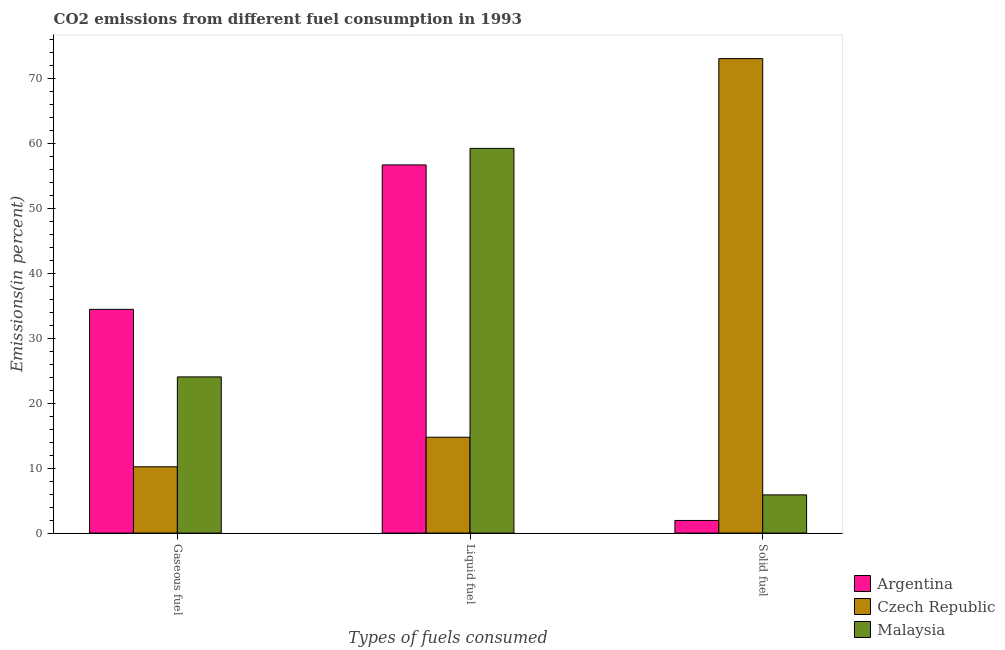How many different coloured bars are there?
Make the answer very short. 3. What is the label of the 2nd group of bars from the left?
Give a very brief answer. Liquid fuel. What is the percentage of gaseous fuel emission in Czech Republic?
Offer a very short reply. 10.2. Across all countries, what is the maximum percentage of liquid fuel emission?
Ensure brevity in your answer.  59.21. Across all countries, what is the minimum percentage of liquid fuel emission?
Provide a succinct answer. 14.75. In which country was the percentage of solid fuel emission maximum?
Provide a succinct answer. Czech Republic. In which country was the percentage of liquid fuel emission minimum?
Give a very brief answer. Czech Republic. What is the total percentage of solid fuel emission in the graph?
Keep it short and to the point. 80.84. What is the difference between the percentage of liquid fuel emission in Malaysia and that in Argentina?
Give a very brief answer. 2.54. What is the difference between the percentage of solid fuel emission in Argentina and the percentage of liquid fuel emission in Czech Republic?
Offer a very short reply. -12.81. What is the average percentage of gaseous fuel emission per country?
Offer a terse response. 22.89. What is the difference between the percentage of liquid fuel emission and percentage of gaseous fuel emission in Malaysia?
Make the answer very short. 35.17. In how many countries, is the percentage of solid fuel emission greater than 40 %?
Offer a terse response. 1. What is the ratio of the percentage of solid fuel emission in Czech Republic to that in Malaysia?
Your answer should be compact. 12.43. Is the percentage of liquid fuel emission in Malaysia less than that in Czech Republic?
Give a very brief answer. No. What is the difference between the highest and the second highest percentage of liquid fuel emission?
Offer a very short reply. 2.54. What is the difference between the highest and the lowest percentage of solid fuel emission?
Give a very brief answer. 71.08. In how many countries, is the percentage of solid fuel emission greater than the average percentage of solid fuel emission taken over all countries?
Your answer should be very brief. 1. Is the sum of the percentage of liquid fuel emission in Czech Republic and Malaysia greater than the maximum percentage of gaseous fuel emission across all countries?
Make the answer very short. Yes. What does the 1st bar from the left in Solid fuel represents?
Your response must be concise. Argentina. What does the 1st bar from the right in Liquid fuel represents?
Your answer should be very brief. Malaysia. Is it the case that in every country, the sum of the percentage of gaseous fuel emission and percentage of liquid fuel emission is greater than the percentage of solid fuel emission?
Your response must be concise. No. Are the values on the major ticks of Y-axis written in scientific E-notation?
Your answer should be very brief. No. Where does the legend appear in the graph?
Ensure brevity in your answer.  Bottom right. What is the title of the graph?
Your response must be concise. CO2 emissions from different fuel consumption in 1993. What is the label or title of the X-axis?
Provide a succinct answer. Types of fuels consumed. What is the label or title of the Y-axis?
Your response must be concise. Emissions(in percent). What is the Emissions(in percent) in Argentina in Gaseous fuel?
Your response must be concise. 34.43. What is the Emissions(in percent) of Czech Republic in Gaseous fuel?
Offer a terse response. 10.2. What is the Emissions(in percent) of Malaysia in Gaseous fuel?
Your response must be concise. 24.04. What is the Emissions(in percent) of Argentina in Liquid fuel?
Make the answer very short. 56.66. What is the Emissions(in percent) in Czech Republic in Liquid fuel?
Your answer should be compact. 14.75. What is the Emissions(in percent) in Malaysia in Liquid fuel?
Your answer should be very brief. 59.21. What is the Emissions(in percent) of Argentina in Solid fuel?
Make the answer very short. 1.94. What is the Emissions(in percent) of Czech Republic in Solid fuel?
Offer a terse response. 73.03. What is the Emissions(in percent) of Malaysia in Solid fuel?
Give a very brief answer. 5.88. Across all Types of fuels consumed, what is the maximum Emissions(in percent) in Argentina?
Your answer should be very brief. 56.66. Across all Types of fuels consumed, what is the maximum Emissions(in percent) in Czech Republic?
Provide a short and direct response. 73.03. Across all Types of fuels consumed, what is the maximum Emissions(in percent) in Malaysia?
Offer a terse response. 59.21. Across all Types of fuels consumed, what is the minimum Emissions(in percent) of Argentina?
Make the answer very short. 1.94. Across all Types of fuels consumed, what is the minimum Emissions(in percent) in Czech Republic?
Ensure brevity in your answer.  10.2. Across all Types of fuels consumed, what is the minimum Emissions(in percent) in Malaysia?
Give a very brief answer. 5.88. What is the total Emissions(in percent) in Argentina in the graph?
Give a very brief answer. 93.03. What is the total Emissions(in percent) of Czech Republic in the graph?
Give a very brief answer. 97.98. What is the total Emissions(in percent) of Malaysia in the graph?
Ensure brevity in your answer.  89.12. What is the difference between the Emissions(in percent) in Argentina in Gaseous fuel and that in Liquid fuel?
Provide a succinct answer. -22.23. What is the difference between the Emissions(in percent) of Czech Republic in Gaseous fuel and that in Liquid fuel?
Offer a very short reply. -4.55. What is the difference between the Emissions(in percent) in Malaysia in Gaseous fuel and that in Liquid fuel?
Provide a succinct answer. -35.17. What is the difference between the Emissions(in percent) of Argentina in Gaseous fuel and that in Solid fuel?
Give a very brief answer. 32.49. What is the difference between the Emissions(in percent) in Czech Republic in Gaseous fuel and that in Solid fuel?
Provide a short and direct response. -62.82. What is the difference between the Emissions(in percent) of Malaysia in Gaseous fuel and that in Solid fuel?
Provide a short and direct response. 18.16. What is the difference between the Emissions(in percent) in Argentina in Liquid fuel and that in Solid fuel?
Provide a succinct answer. 54.72. What is the difference between the Emissions(in percent) of Czech Republic in Liquid fuel and that in Solid fuel?
Offer a terse response. -58.28. What is the difference between the Emissions(in percent) of Malaysia in Liquid fuel and that in Solid fuel?
Ensure brevity in your answer.  53.33. What is the difference between the Emissions(in percent) in Argentina in Gaseous fuel and the Emissions(in percent) in Czech Republic in Liquid fuel?
Offer a terse response. 19.68. What is the difference between the Emissions(in percent) in Argentina in Gaseous fuel and the Emissions(in percent) in Malaysia in Liquid fuel?
Your answer should be compact. -24.77. What is the difference between the Emissions(in percent) in Czech Republic in Gaseous fuel and the Emissions(in percent) in Malaysia in Liquid fuel?
Provide a succinct answer. -49. What is the difference between the Emissions(in percent) of Argentina in Gaseous fuel and the Emissions(in percent) of Czech Republic in Solid fuel?
Provide a succinct answer. -38.59. What is the difference between the Emissions(in percent) in Argentina in Gaseous fuel and the Emissions(in percent) in Malaysia in Solid fuel?
Offer a very short reply. 28.55. What is the difference between the Emissions(in percent) of Czech Republic in Gaseous fuel and the Emissions(in percent) of Malaysia in Solid fuel?
Provide a short and direct response. 4.33. What is the difference between the Emissions(in percent) in Argentina in Liquid fuel and the Emissions(in percent) in Czech Republic in Solid fuel?
Provide a succinct answer. -16.36. What is the difference between the Emissions(in percent) of Argentina in Liquid fuel and the Emissions(in percent) of Malaysia in Solid fuel?
Keep it short and to the point. 50.78. What is the difference between the Emissions(in percent) in Czech Republic in Liquid fuel and the Emissions(in percent) in Malaysia in Solid fuel?
Your response must be concise. 8.87. What is the average Emissions(in percent) in Argentina per Types of fuels consumed?
Provide a succinct answer. 31.01. What is the average Emissions(in percent) in Czech Republic per Types of fuels consumed?
Your answer should be compact. 32.66. What is the average Emissions(in percent) in Malaysia per Types of fuels consumed?
Offer a very short reply. 29.71. What is the difference between the Emissions(in percent) in Argentina and Emissions(in percent) in Czech Republic in Gaseous fuel?
Make the answer very short. 24.23. What is the difference between the Emissions(in percent) in Argentina and Emissions(in percent) in Malaysia in Gaseous fuel?
Ensure brevity in your answer.  10.4. What is the difference between the Emissions(in percent) in Czech Republic and Emissions(in percent) in Malaysia in Gaseous fuel?
Offer a very short reply. -13.83. What is the difference between the Emissions(in percent) in Argentina and Emissions(in percent) in Czech Republic in Liquid fuel?
Your response must be concise. 41.91. What is the difference between the Emissions(in percent) in Argentina and Emissions(in percent) in Malaysia in Liquid fuel?
Your answer should be compact. -2.54. What is the difference between the Emissions(in percent) in Czech Republic and Emissions(in percent) in Malaysia in Liquid fuel?
Ensure brevity in your answer.  -44.46. What is the difference between the Emissions(in percent) in Argentina and Emissions(in percent) in Czech Republic in Solid fuel?
Offer a very short reply. -71.08. What is the difference between the Emissions(in percent) of Argentina and Emissions(in percent) of Malaysia in Solid fuel?
Make the answer very short. -3.94. What is the difference between the Emissions(in percent) in Czech Republic and Emissions(in percent) in Malaysia in Solid fuel?
Provide a succinct answer. 67.15. What is the ratio of the Emissions(in percent) of Argentina in Gaseous fuel to that in Liquid fuel?
Provide a short and direct response. 0.61. What is the ratio of the Emissions(in percent) in Czech Republic in Gaseous fuel to that in Liquid fuel?
Provide a short and direct response. 0.69. What is the ratio of the Emissions(in percent) in Malaysia in Gaseous fuel to that in Liquid fuel?
Provide a short and direct response. 0.41. What is the ratio of the Emissions(in percent) in Argentina in Gaseous fuel to that in Solid fuel?
Keep it short and to the point. 17.73. What is the ratio of the Emissions(in percent) of Czech Republic in Gaseous fuel to that in Solid fuel?
Your response must be concise. 0.14. What is the ratio of the Emissions(in percent) in Malaysia in Gaseous fuel to that in Solid fuel?
Ensure brevity in your answer.  4.09. What is the ratio of the Emissions(in percent) in Argentina in Liquid fuel to that in Solid fuel?
Keep it short and to the point. 29.18. What is the ratio of the Emissions(in percent) in Czech Republic in Liquid fuel to that in Solid fuel?
Make the answer very short. 0.2. What is the ratio of the Emissions(in percent) in Malaysia in Liquid fuel to that in Solid fuel?
Your response must be concise. 10.07. What is the difference between the highest and the second highest Emissions(in percent) of Argentina?
Ensure brevity in your answer.  22.23. What is the difference between the highest and the second highest Emissions(in percent) in Czech Republic?
Offer a terse response. 58.28. What is the difference between the highest and the second highest Emissions(in percent) in Malaysia?
Your answer should be very brief. 35.17. What is the difference between the highest and the lowest Emissions(in percent) of Argentina?
Your response must be concise. 54.72. What is the difference between the highest and the lowest Emissions(in percent) in Czech Republic?
Your answer should be very brief. 62.82. What is the difference between the highest and the lowest Emissions(in percent) of Malaysia?
Your answer should be compact. 53.33. 